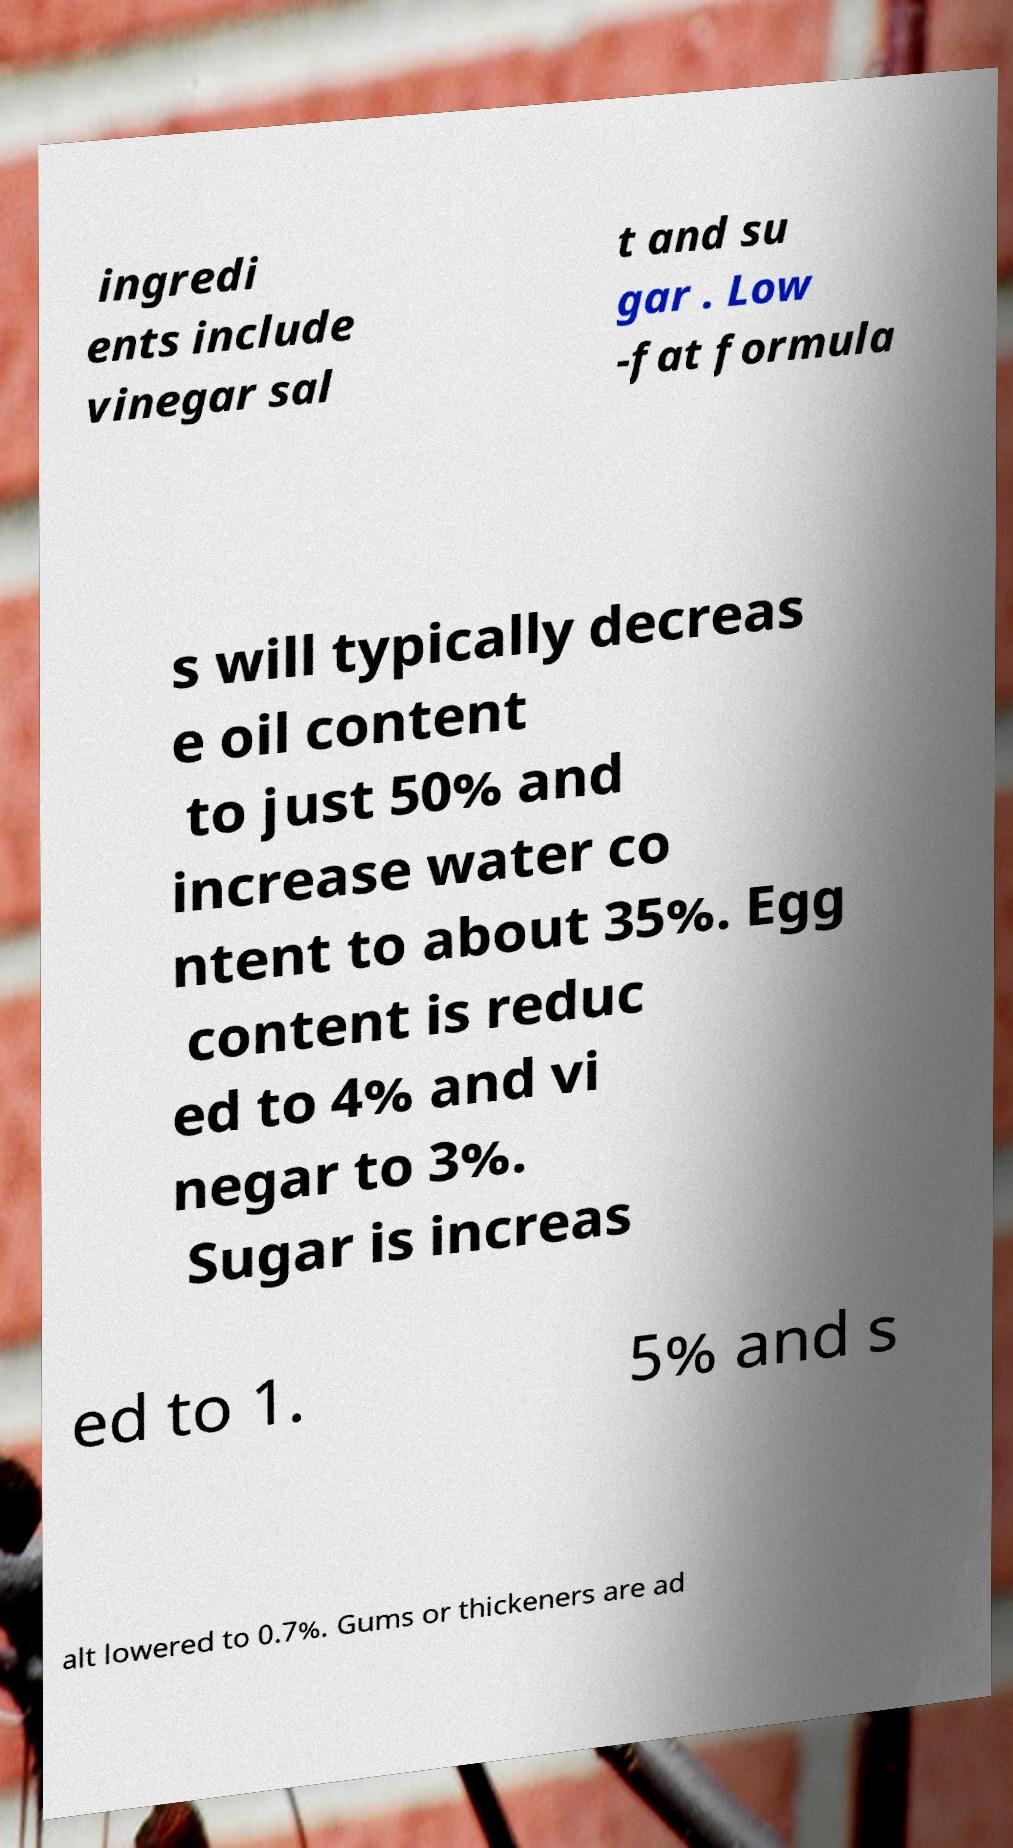Could you extract and type out the text from this image? ingredi ents include vinegar sal t and su gar . Low -fat formula s will typically decreas e oil content to just 50% and increase water co ntent to about 35%. Egg content is reduc ed to 4% and vi negar to 3%. Sugar is increas ed to 1. 5% and s alt lowered to 0.7%. Gums or thickeners are ad 